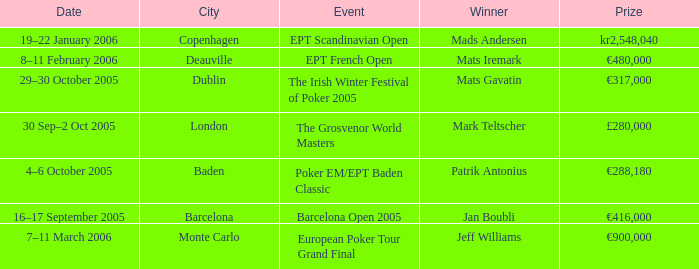What event did Mark Teltscher win? The Grosvenor World Masters. 